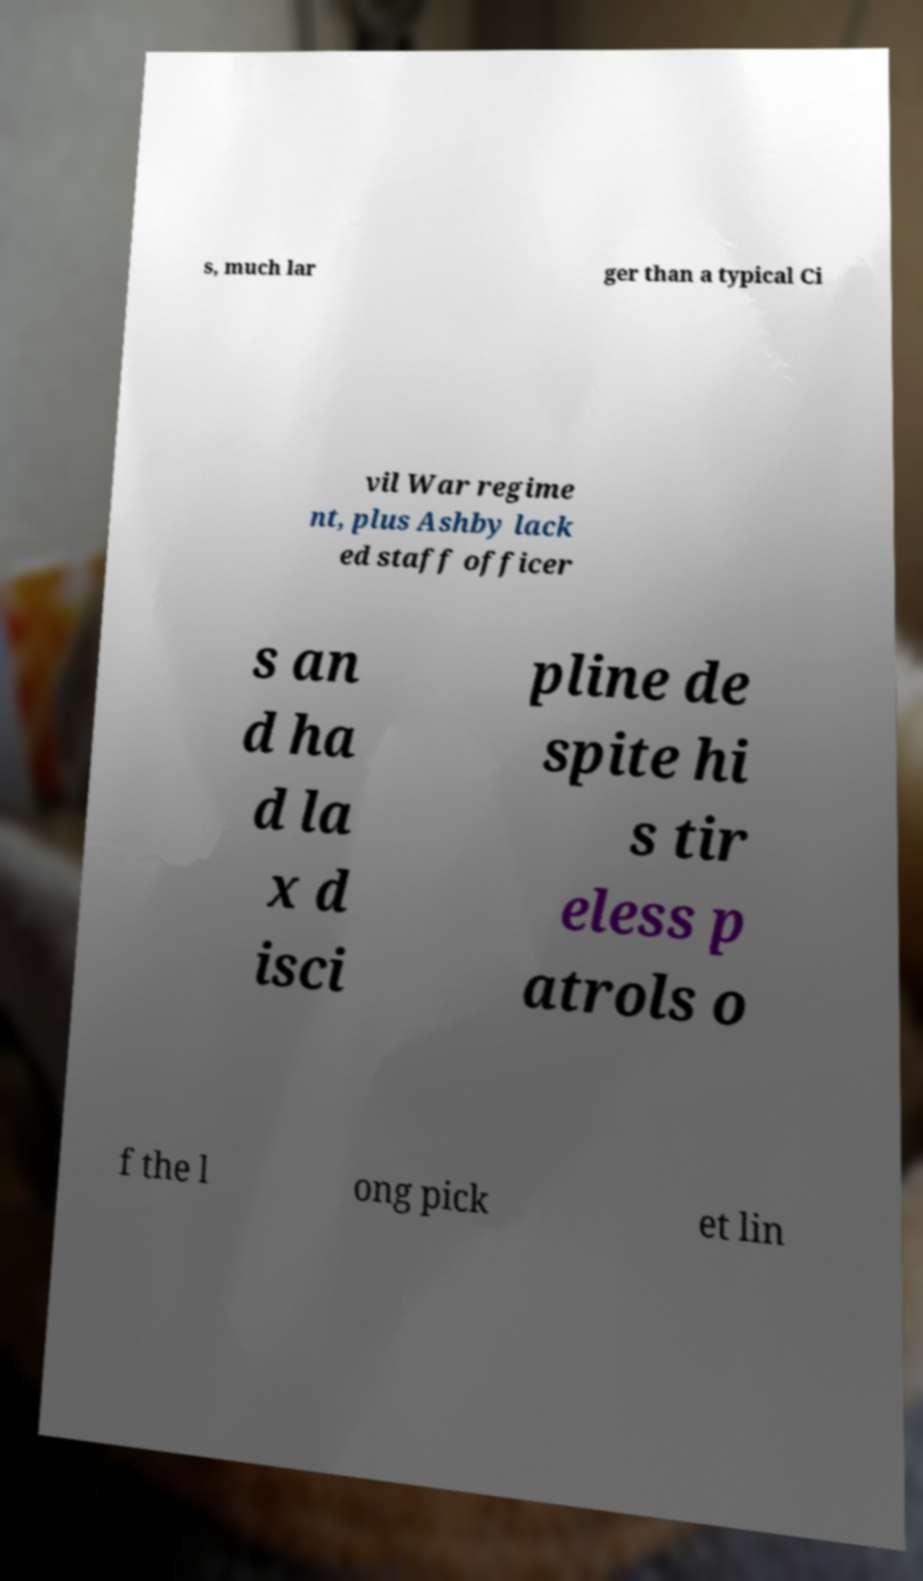For documentation purposes, I need the text within this image transcribed. Could you provide that? s, much lar ger than a typical Ci vil War regime nt, plus Ashby lack ed staff officer s an d ha d la x d isci pline de spite hi s tir eless p atrols o f the l ong pick et lin 